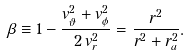<formula> <loc_0><loc_0><loc_500><loc_500>\beta \equiv 1 - \frac { v _ { \vartheta } ^ { 2 } + v _ { \phi } ^ { 2 } } { 2 \, v _ { r } ^ { 2 } } = \frac { r ^ { 2 } } { r ^ { 2 } + r _ { a } ^ { 2 } } .</formula> 